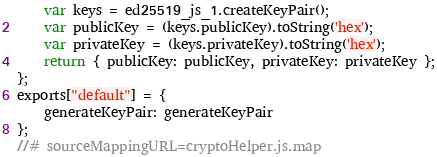<code> <loc_0><loc_0><loc_500><loc_500><_JavaScript_>    var keys = ed25519_js_1.createKeyPair();
    var publicKey = (keys.publicKey).toString('hex');
    var privateKey = (keys.privateKey).toString('hex');
    return { publicKey: publicKey, privateKey: privateKey };
};
exports["default"] = {
    generateKeyPair: generateKeyPair
};
//# sourceMappingURL=cryptoHelper.js.map</code> 